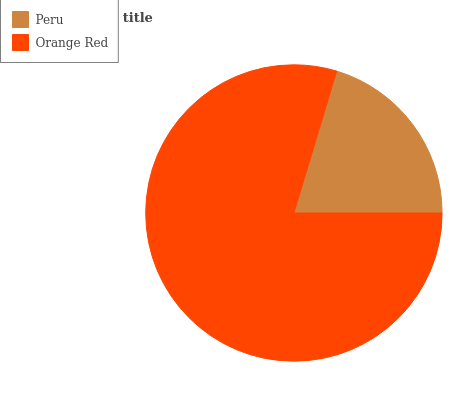Is Peru the minimum?
Answer yes or no. Yes. Is Orange Red the maximum?
Answer yes or no. Yes. Is Orange Red the minimum?
Answer yes or no. No. Is Orange Red greater than Peru?
Answer yes or no. Yes. Is Peru less than Orange Red?
Answer yes or no. Yes. Is Peru greater than Orange Red?
Answer yes or no. No. Is Orange Red less than Peru?
Answer yes or no. No. Is Orange Red the high median?
Answer yes or no. Yes. Is Peru the low median?
Answer yes or no. Yes. Is Peru the high median?
Answer yes or no. No. Is Orange Red the low median?
Answer yes or no. No. 